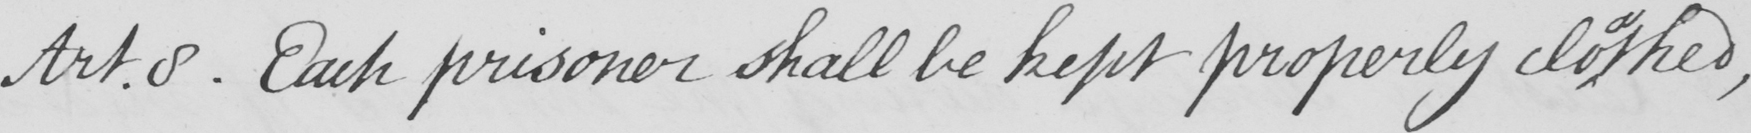Transcribe the text shown in this historical manuscript line. Art.8. Each prisoner shall be kept properly clo thed, 